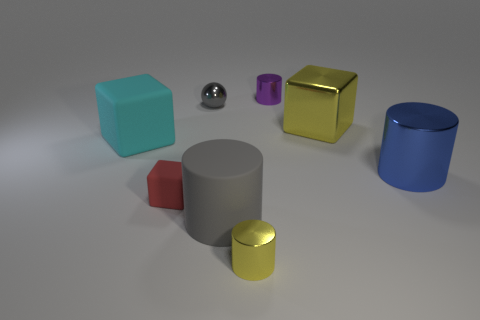There is a cyan matte object; is it the same size as the red thing that is on the left side of the gray metal ball?
Provide a succinct answer. No. The small rubber cube has what color?
Make the answer very short. Red. What is the shape of the yellow thing on the right side of the yellow metal object that is to the left of the shiny cylinder that is behind the cyan rubber block?
Provide a succinct answer. Cube. There is a big object that is on the right side of the large yellow cube in front of the purple shiny cylinder; what is its material?
Your answer should be very brief. Metal. What is the shape of the big blue object that is the same material as the purple thing?
Offer a very short reply. Cylinder. Is there any other thing that is the same shape as the large gray rubber object?
Your answer should be very brief. Yes. There is a blue cylinder; how many large yellow metallic blocks are right of it?
Your answer should be compact. 0. Are any big purple matte cubes visible?
Keep it short and to the point. No. What is the color of the shiny object to the left of the small cylinder in front of the matte cylinder right of the small gray thing?
Your response must be concise. Gray. There is a small metallic cylinder left of the tiny purple metal object; is there a cylinder that is in front of it?
Give a very brief answer. No. 